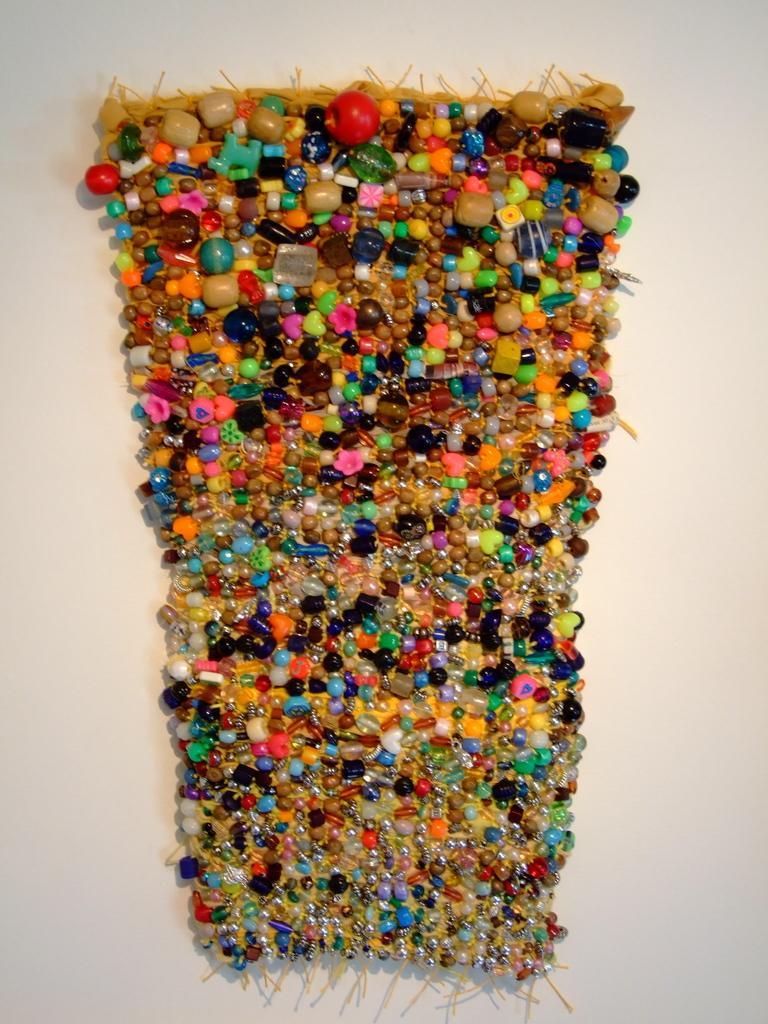How would you summarize this image in a sentence or two? In this image we can see a colorful object on the white color surface. 